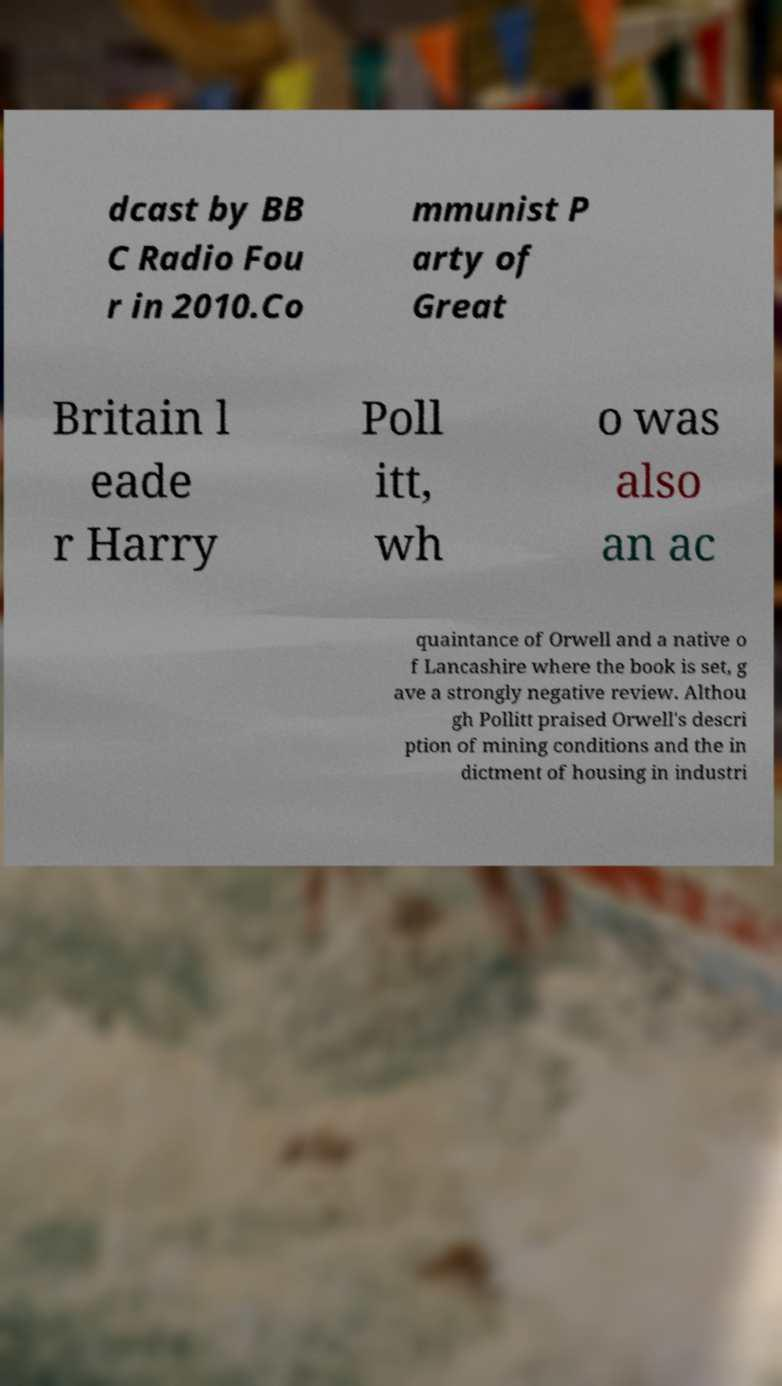Can you accurately transcribe the text from the provided image for me? dcast by BB C Radio Fou r in 2010.Co mmunist P arty of Great Britain l eade r Harry Poll itt, wh o was also an ac quaintance of Orwell and a native o f Lancashire where the book is set, g ave a strongly negative review. Althou gh Pollitt praised Orwell's descri ption of mining conditions and the in dictment of housing in industri 